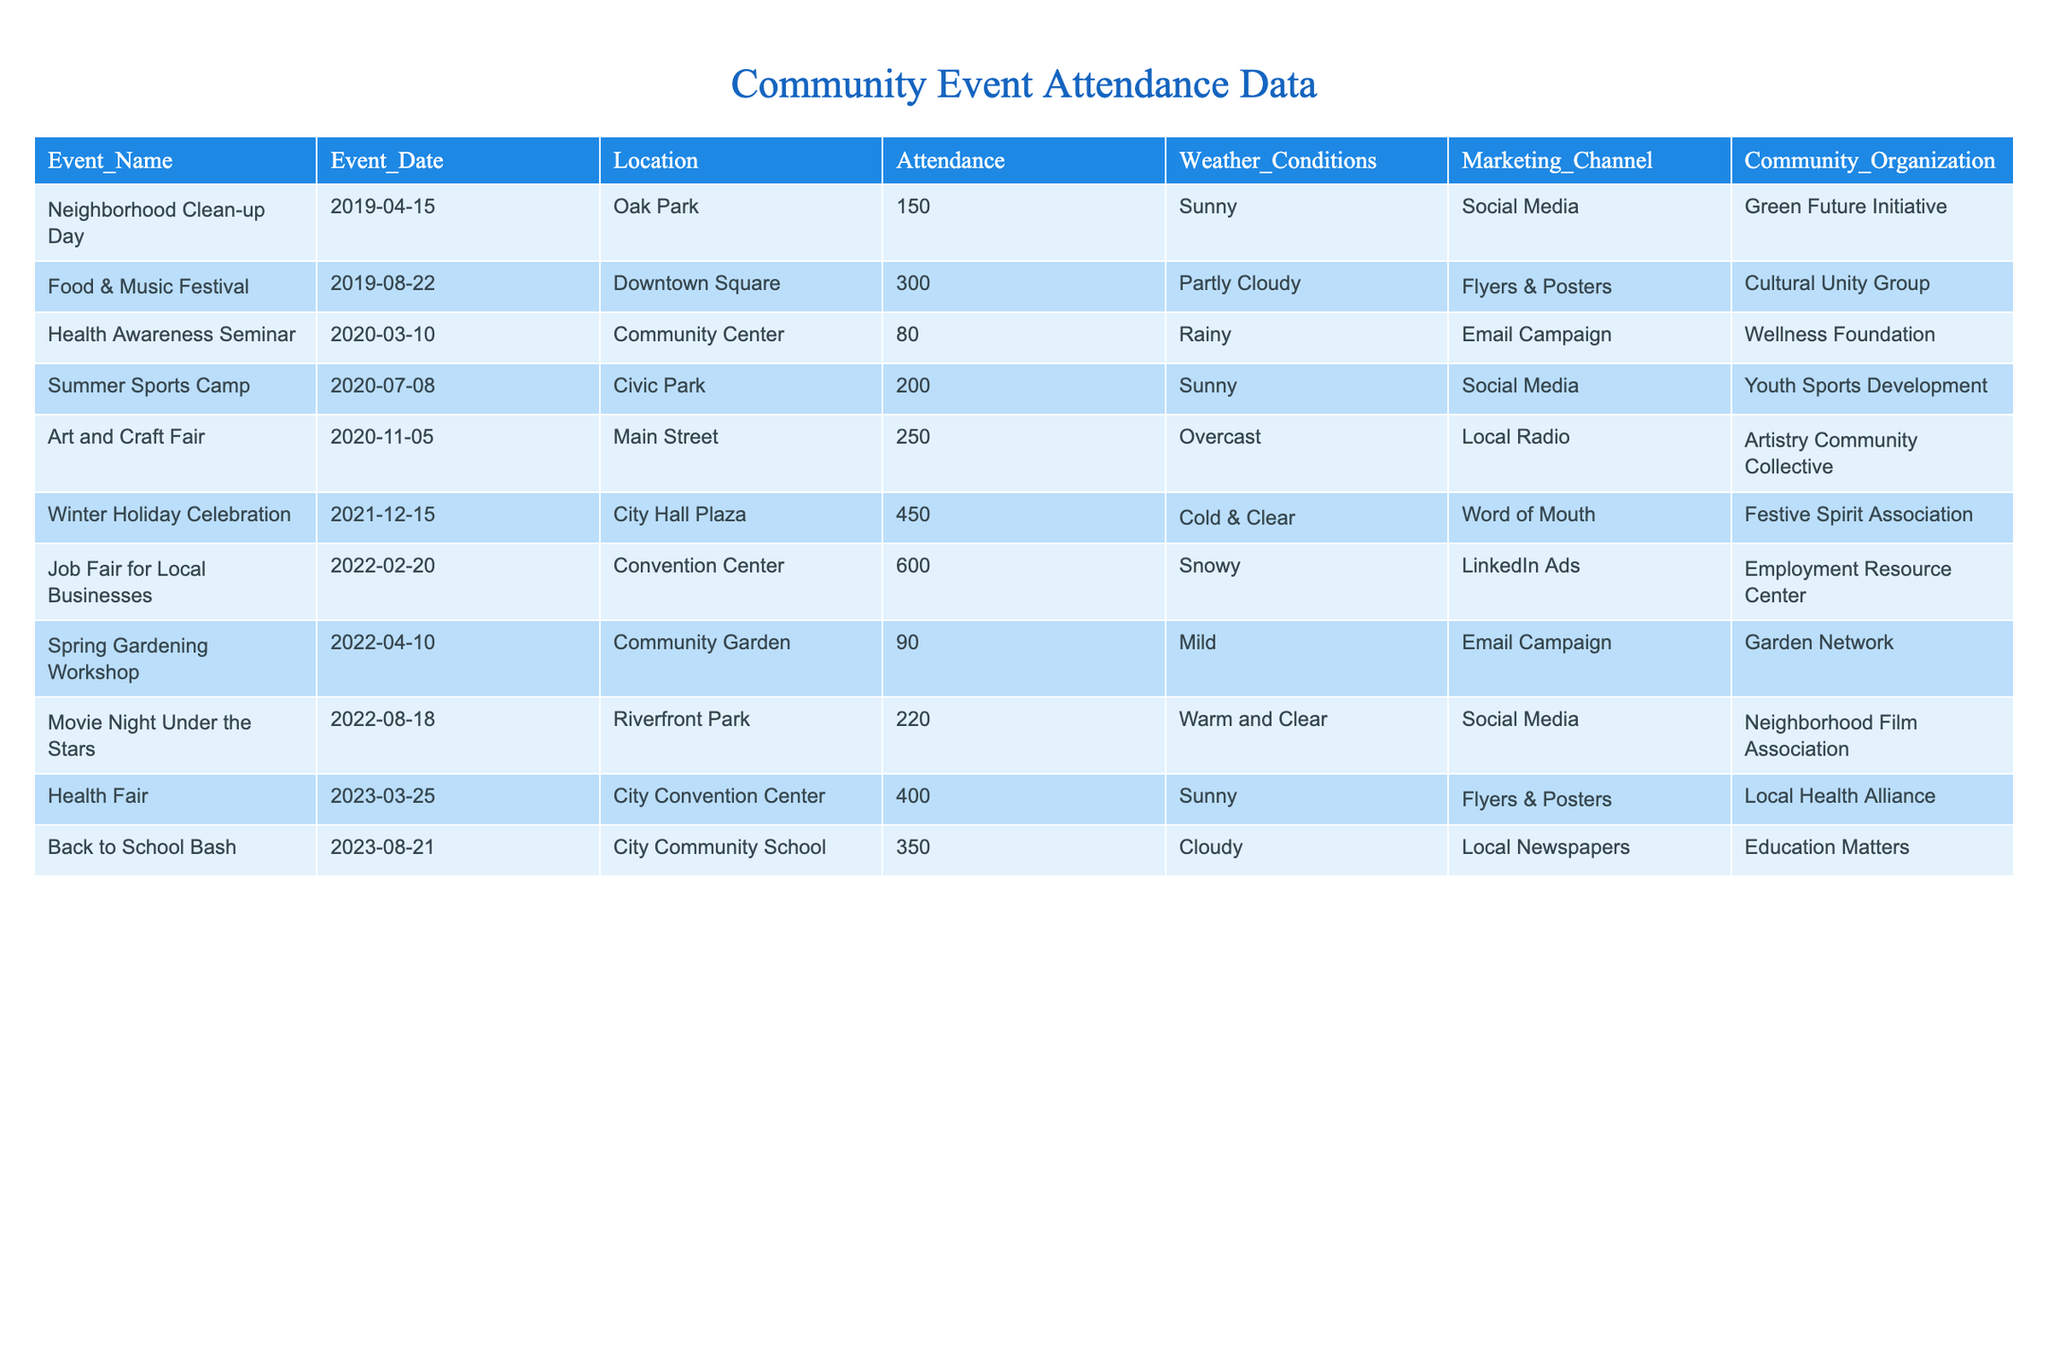What was the highest attendance at a community event in the past five years? The highest attendance is found by examining the "Attendance" column in the table. The Job Fair for Local Businesses in 2022 had an attendance of 600, which is greater than all other events.
Answer: 600 Which event had the lowest attendance? To determine which event had the lowest attendance, we check the "Attendance" column. The Health Awareness Seminar in 2020 had an attendance of 80, which is the minimum value in the column.
Answer: 80 How many events had an attendance of over 300? We can count events with attendance greater than 300 by analyzing the "Attendance" column. The Food & Music Festival, Winter Holiday Celebration, Job Fair for Local Businesses, Health Fair, and Back to School Bash exceed this value, totaling 5 events.
Answer: 5 What is the average attendance across all events? The average attendance is calculated by adding all attendance values (150 + 300 + 80 + 200 + 250 + 450 + 600 + 90 + 220 + 400 + 350 = 3190) and dividing by the number of events (11). Therefore, average attendance is 3190 / 11 ≈ 290.
Answer: 290 Did any event take place during rainy weather? We check the "Weather Conditions" column for any mention of "Rainy." The Health Awareness Seminar in 2020 was the only event listed under rainy conditions.
Answer: Yes How many events were held in the community center? By checking the "Location" column, we find events listed as taking place in the community center. There are two events: Health Awareness Seminar (2020) and Health Fair (2023).
Answer: 2 What is the total attendance for events that were promoted through Social Media? For this question, we look at the "Marketing Channel" column and sum the attendance for the events that used Social Media: Neighborhood Clean-up Day (150), Summer Sports Camp (200), Movie Night Under the Stars (220). The total attendance is 150 + 200 + 220 = 570.
Answer: 570 Which event occurred on the latest date? To find the event with the latest date, we look at the "Event_Date" column and find that "Back to School Bash" occurred on 2023-08-21, which is the most recent date listed in the table.
Answer: Back to School Bash How many events had a date in 2022? Checking the "Event_Date," we can list the events held in 2022: Job Fair for Local Businesses and Spring Gardening Workshop. Thus, there are 2 events in 2022.
Answer: 2 Was there any event with an attendance greater than 400 that also took place in a park? We need to identify events that both had attendance above 400 and are located in parks. The only event with attendance above 400 is the Job Fair for Local Businesses, which took place in the Convention Center, not in a park. Thus, there are no such events.
Answer: No 